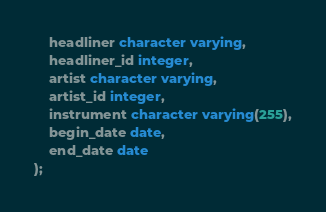Convert code to text. <code><loc_0><loc_0><loc_500><loc_500><_SQL_>    headliner character varying,
    headliner_id integer,
    artist character varying,
    artist_id integer,
    instrument character varying(255),
    begin_date date,
    end_date date
);</code> 